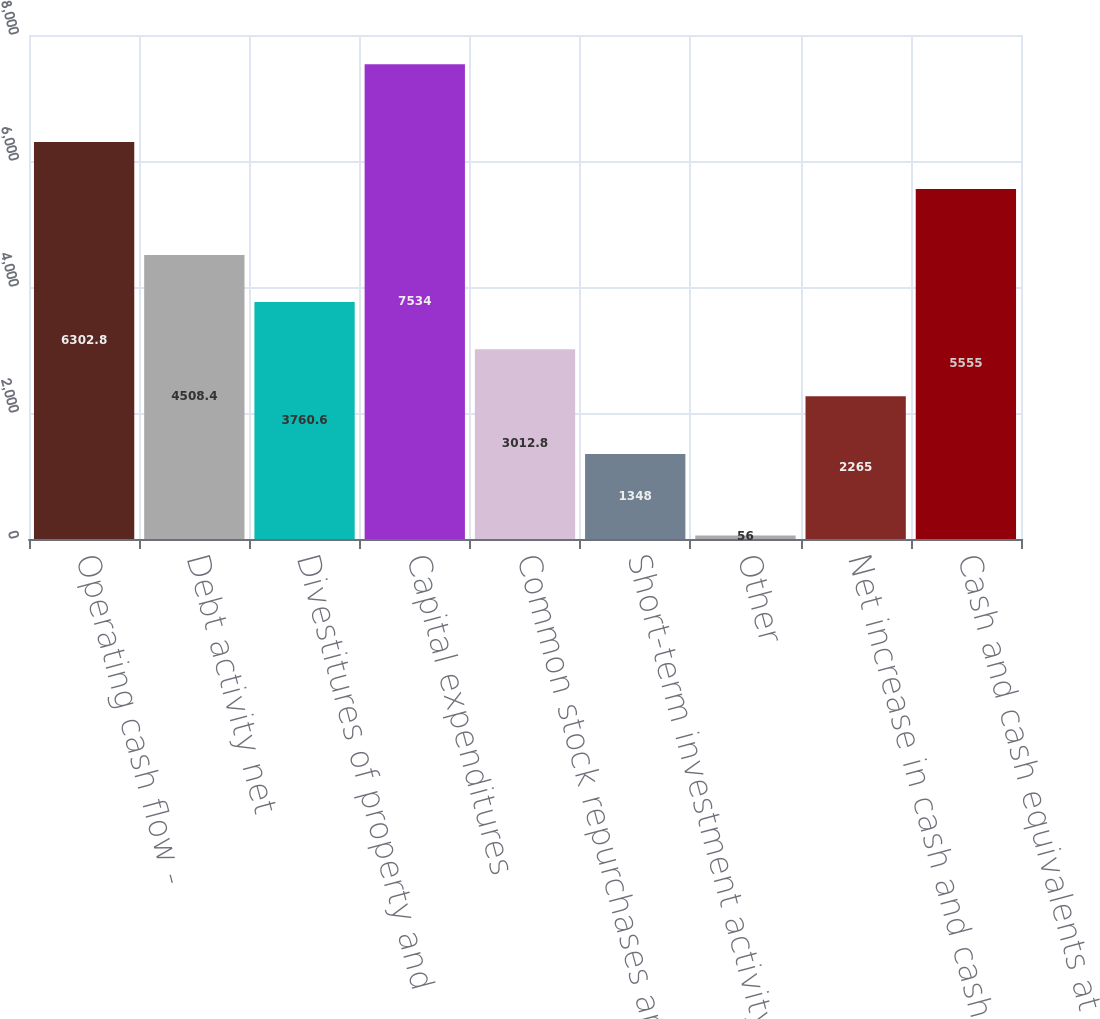Convert chart to OTSL. <chart><loc_0><loc_0><loc_500><loc_500><bar_chart><fcel>Operating cash flow -<fcel>Debt activity net<fcel>Divestitures of property and<fcel>Capital expenditures<fcel>Common stock repurchases and<fcel>Short-term investment activity<fcel>Other<fcel>Net increase in cash and cash<fcel>Cash and cash equivalents at<nl><fcel>6302.8<fcel>4508.4<fcel>3760.6<fcel>7534<fcel>3012.8<fcel>1348<fcel>56<fcel>2265<fcel>5555<nl></chart> 